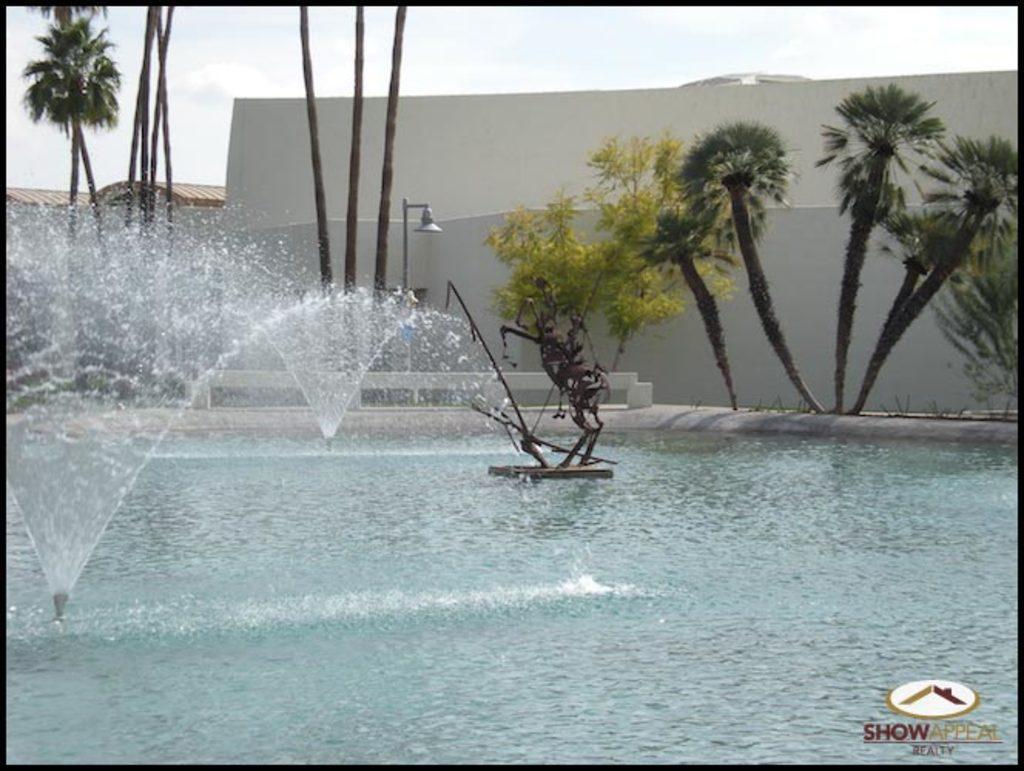Describe this image in one or two sentences. In this image I can see the statue and fountains on the water. In the background there are many trees, light pole and the wall. In the background I can see the sky. 